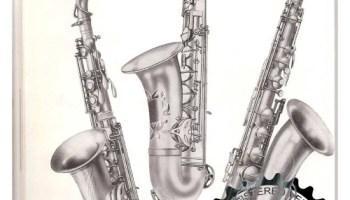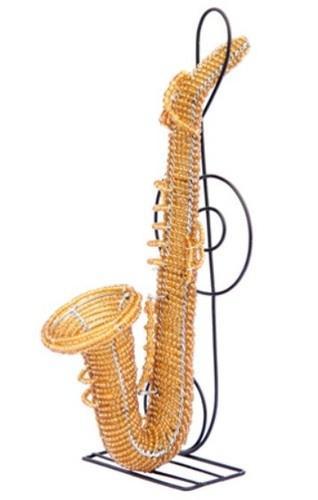The first image is the image on the left, the second image is the image on the right. Given the left and right images, does the statement "An image shows a row of at least four instruments, and the one on the far left does not have an upturned bell." hold true? Answer yes or no. No. The first image is the image on the left, the second image is the image on the right. For the images displayed, is the sentence "More than three different types of instruments are shown in one photo with one of them being a saxophone that is straight." factually correct? Answer yes or no. No. 